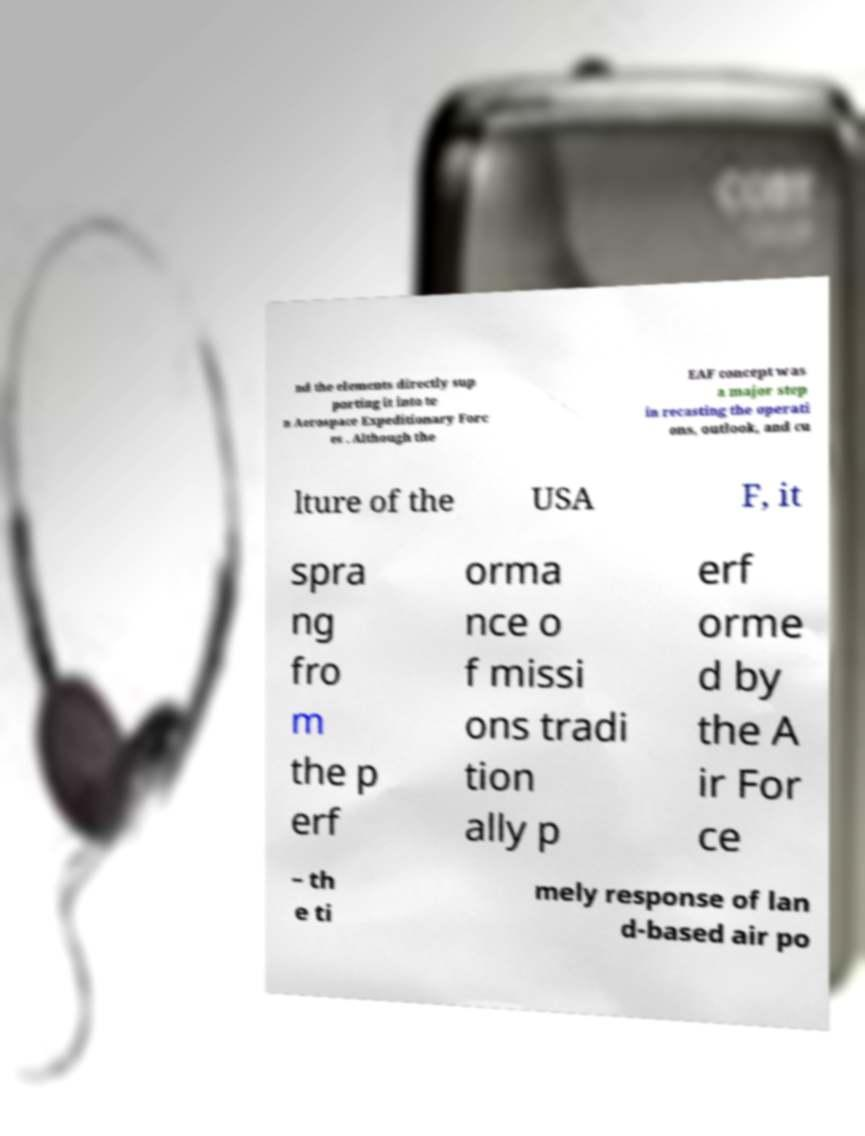I need the written content from this picture converted into text. Can you do that? nd the elements directly sup porting it into te n Aerospace Expeditionary Forc es . Although the EAF concept was a major step in recasting the operati ons, outlook, and cu lture of the USA F, it spra ng fro m the p erf orma nce o f missi ons tradi tion ally p erf orme d by the A ir For ce – th e ti mely response of lan d-based air po 